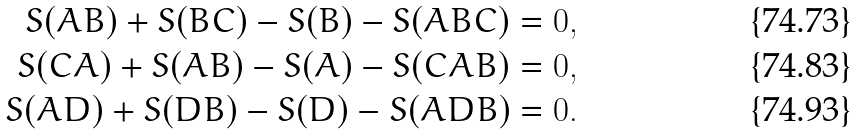Convert formula to latex. <formula><loc_0><loc_0><loc_500><loc_500>S ( A B ) + S ( B C ) - S ( B ) - S ( A B C ) & = 0 , \\ S ( C A ) + S ( A B ) - S ( A ) - S ( C A B ) & = 0 , \\ S ( A D ) + S ( D B ) - S ( D ) - S ( A D B ) & = 0 .</formula> 